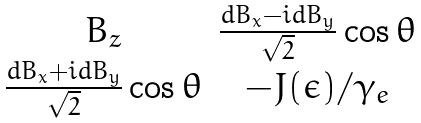<formula> <loc_0><loc_0><loc_500><loc_500>\begin{matrix} B _ { z } & \frac { d B _ { x } - i d B _ { y } } { \sqrt { 2 } } \cos \theta \\ \frac { d B _ { x } + i d B _ { y } } { \sqrt { 2 } } \cos \theta & - J ( \epsilon ) / \gamma _ { e } \end{matrix}</formula> 